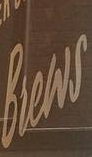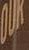What words are shown in these images in order, separated by a semicolon? Brews; OUK 